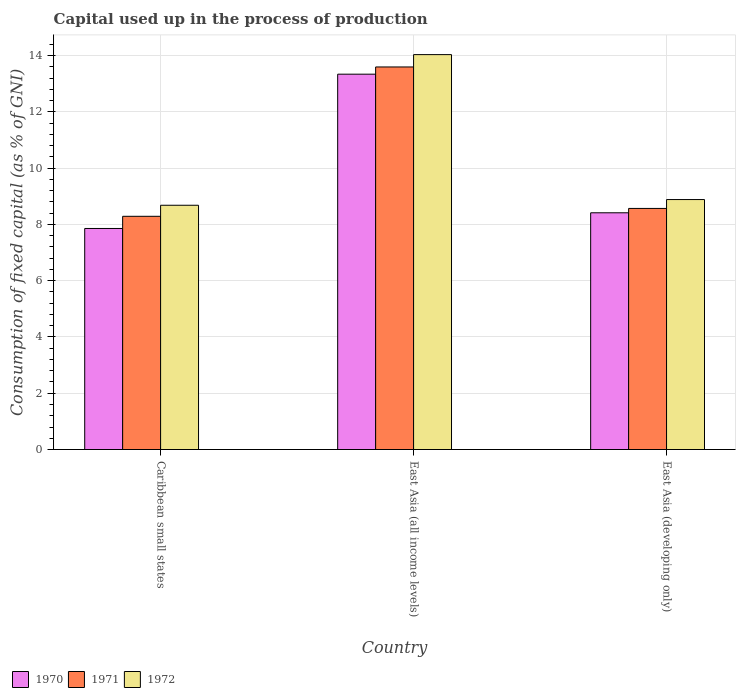How many different coloured bars are there?
Your answer should be compact. 3. How many groups of bars are there?
Offer a terse response. 3. Are the number of bars per tick equal to the number of legend labels?
Offer a very short reply. Yes. Are the number of bars on each tick of the X-axis equal?
Your response must be concise. Yes. How many bars are there on the 2nd tick from the left?
Your response must be concise. 3. What is the label of the 3rd group of bars from the left?
Your response must be concise. East Asia (developing only). In how many cases, is the number of bars for a given country not equal to the number of legend labels?
Provide a short and direct response. 0. What is the capital used up in the process of production in 1972 in East Asia (all income levels)?
Your answer should be compact. 14.03. Across all countries, what is the maximum capital used up in the process of production in 1971?
Keep it short and to the point. 13.59. Across all countries, what is the minimum capital used up in the process of production in 1971?
Give a very brief answer. 8.29. In which country was the capital used up in the process of production in 1972 maximum?
Keep it short and to the point. East Asia (all income levels). In which country was the capital used up in the process of production in 1970 minimum?
Offer a terse response. Caribbean small states. What is the total capital used up in the process of production in 1970 in the graph?
Provide a short and direct response. 29.6. What is the difference between the capital used up in the process of production in 1970 in Caribbean small states and that in East Asia (all income levels)?
Provide a short and direct response. -5.48. What is the difference between the capital used up in the process of production in 1972 in East Asia (all income levels) and the capital used up in the process of production in 1970 in East Asia (developing only)?
Give a very brief answer. 5.62. What is the average capital used up in the process of production in 1972 per country?
Provide a short and direct response. 10.53. What is the difference between the capital used up in the process of production of/in 1970 and capital used up in the process of production of/in 1971 in East Asia (developing only)?
Offer a very short reply. -0.16. In how many countries, is the capital used up in the process of production in 1971 greater than 12.8 %?
Your answer should be compact. 1. What is the ratio of the capital used up in the process of production in 1972 in Caribbean small states to that in East Asia (all income levels)?
Ensure brevity in your answer.  0.62. What is the difference between the highest and the second highest capital used up in the process of production in 1972?
Offer a very short reply. 0.2. What is the difference between the highest and the lowest capital used up in the process of production in 1972?
Ensure brevity in your answer.  5.35. Is the sum of the capital used up in the process of production in 1970 in East Asia (all income levels) and East Asia (developing only) greater than the maximum capital used up in the process of production in 1971 across all countries?
Offer a very short reply. Yes. What does the 2nd bar from the left in Caribbean small states represents?
Your response must be concise. 1971. What does the 3rd bar from the right in Caribbean small states represents?
Offer a very short reply. 1970. Is it the case that in every country, the sum of the capital used up in the process of production in 1972 and capital used up in the process of production in 1970 is greater than the capital used up in the process of production in 1971?
Offer a very short reply. Yes. How many bars are there?
Provide a short and direct response. 9. What is the difference between two consecutive major ticks on the Y-axis?
Offer a terse response. 2. Are the values on the major ticks of Y-axis written in scientific E-notation?
Provide a short and direct response. No. Does the graph contain any zero values?
Provide a succinct answer. No. Where does the legend appear in the graph?
Provide a succinct answer. Bottom left. What is the title of the graph?
Give a very brief answer. Capital used up in the process of production. What is the label or title of the Y-axis?
Offer a terse response. Consumption of fixed capital (as % of GNI). What is the Consumption of fixed capital (as % of GNI) in 1970 in Caribbean small states?
Your answer should be very brief. 7.85. What is the Consumption of fixed capital (as % of GNI) in 1971 in Caribbean small states?
Provide a succinct answer. 8.29. What is the Consumption of fixed capital (as % of GNI) of 1972 in Caribbean small states?
Your response must be concise. 8.68. What is the Consumption of fixed capital (as % of GNI) in 1970 in East Asia (all income levels)?
Provide a succinct answer. 13.34. What is the Consumption of fixed capital (as % of GNI) in 1971 in East Asia (all income levels)?
Provide a short and direct response. 13.59. What is the Consumption of fixed capital (as % of GNI) of 1972 in East Asia (all income levels)?
Offer a very short reply. 14.03. What is the Consumption of fixed capital (as % of GNI) in 1970 in East Asia (developing only)?
Your response must be concise. 8.41. What is the Consumption of fixed capital (as % of GNI) in 1971 in East Asia (developing only)?
Keep it short and to the point. 8.57. What is the Consumption of fixed capital (as % of GNI) of 1972 in East Asia (developing only)?
Your answer should be compact. 8.88. Across all countries, what is the maximum Consumption of fixed capital (as % of GNI) in 1970?
Give a very brief answer. 13.34. Across all countries, what is the maximum Consumption of fixed capital (as % of GNI) in 1971?
Offer a very short reply. 13.59. Across all countries, what is the maximum Consumption of fixed capital (as % of GNI) in 1972?
Provide a short and direct response. 14.03. Across all countries, what is the minimum Consumption of fixed capital (as % of GNI) in 1970?
Offer a terse response. 7.85. Across all countries, what is the minimum Consumption of fixed capital (as % of GNI) in 1971?
Provide a short and direct response. 8.29. Across all countries, what is the minimum Consumption of fixed capital (as % of GNI) of 1972?
Give a very brief answer. 8.68. What is the total Consumption of fixed capital (as % of GNI) in 1970 in the graph?
Keep it short and to the point. 29.6. What is the total Consumption of fixed capital (as % of GNI) in 1971 in the graph?
Ensure brevity in your answer.  30.45. What is the total Consumption of fixed capital (as % of GNI) in 1972 in the graph?
Offer a terse response. 31.59. What is the difference between the Consumption of fixed capital (as % of GNI) of 1970 in Caribbean small states and that in East Asia (all income levels)?
Keep it short and to the point. -5.48. What is the difference between the Consumption of fixed capital (as % of GNI) of 1971 in Caribbean small states and that in East Asia (all income levels)?
Give a very brief answer. -5.31. What is the difference between the Consumption of fixed capital (as % of GNI) of 1972 in Caribbean small states and that in East Asia (all income levels)?
Offer a very short reply. -5.35. What is the difference between the Consumption of fixed capital (as % of GNI) in 1970 in Caribbean small states and that in East Asia (developing only)?
Keep it short and to the point. -0.56. What is the difference between the Consumption of fixed capital (as % of GNI) of 1971 in Caribbean small states and that in East Asia (developing only)?
Your response must be concise. -0.28. What is the difference between the Consumption of fixed capital (as % of GNI) of 1972 in Caribbean small states and that in East Asia (developing only)?
Provide a succinct answer. -0.2. What is the difference between the Consumption of fixed capital (as % of GNI) of 1970 in East Asia (all income levels) and that in East Asia (developing only)?
Make the answer very short. 4.93. What is the difference between the Consumption of fixed capital (as % of GNI) of 1971 in East Asia (all income levels) and that in East Asia (developing only)?
Make the answer very short. 5.03. What is the difference between the Consumption of fixed capital (as % of GNI) of 1972 in East Asia (all income levels) and that in East Asia (developing only)?
Provide a succinct answer. 5.15. What is the difference between the Consumption of fixed capital (as % of GNI) of 1970 in Caribbean small states and the Consumption of fixed capital (as % of GNI) of 1971 in East Asia (all income levels)?
Your answer should be compact. -5.74. What is the difference between the Consumption of fixed capital (as % of GNI) of 1970 in Caribbean small states and the Consumption of fixed capital (as % of GNI) of 1972 in East Asia (all income levels)?
Keep it short and to the point. -6.18. What is the difference between the Consumption of fixed capital (as % of GNI) in 1971 in Caribbean small states and the Consumption of fixed capital (as % of GNI) in 1972 in East Asia (all income levels)?
Provide a short and direct response. -5.75. What is the difference between the Consumption of fixed capital (as % of GNI) in 1970 in Caribbean small states and the Consumption of fixed capital (as % of GNI) in 1971 in East Asia (developing only)?
Offer a terse response. -0.71. What is the difference between the Consumption of fixed capital (as % of GNI) in 1970 in Caribbean small states and the Consumption of fixed capital (as % of GNI) in 1972 in East Asia (developing only)?
Offer a very short reply. -1.03. What is the difference between the Consumption of fixed capital (as % of GNI) of 1971 in Caribbean small states and the Consumption of fixed capital (as % of GNI) of 1972 in East Asia (developing only)?
Your answer should be compact. -0.6. What is the difference between the Consumption of fixed capital (as % of GNI) in 1970 in East Asia (all income levels) and the Consumption of fixed capital (as % of GNI) in 1971 in East Asia (developing only)?
Keep it short and to the point. 4.77. What is the difference between the Consumption of fixed capital (as % of GNI) of 1970 in East Asia (all income levels) and the Consumption of fixed capital (as % of GNI) of 1972 in East Asia (developing only)?
Your response must be concise. 4.45. What is the difference between the Consumption of fixed capital (as % of GNI) of 1971 in East Asia (all income levels) and the Consumption of fixed capital (as % of GNI) of 1972 in East Asia (developing only)?
Give a very brief answer. 4.71. What is the average Consumption of fixed capital (as % of GNI) in 1970 per country?
Ensure brevity in your answer.  9.87. What is the average Consumption of fixed capital (as % of GNI) in 1971 per country?
Your response must be concise. 10.15. What is the average Consumption of fixed capital (as % of GNI) of 1972 per country?
Provide a succinct answer. 10.53. What is the difference between the Consumption of fixed capital (as % of GNI) of 1970 and Consumption of fixed capital (as % of GNI) of 1971 in Caribbean small states?
Offer a very short reply. -0.43. What is the difference between the Consumption of fixed capital (as % of GNI) of 1970 and Consumption of fixed capital (as % of GNI) of 1972 in Caribbean small states?
Your response must be concise. -0.83. What is the difference between the Consumption of fixed capital (as % of GNI) in 1971 and Consumption of fixed capital (as % of GNI) in 1972 in Caribbean small states?
Offer a very short reply. -0.39. What is the difference between the Consumption of fixed capital (as % of GNI) of 1970 and Consumption of fixed capital (as % of GNI) of 1971 in East Asia (all income levels)?
Ensure brevity in your answer.  -0.26. What is the difference between the Consumption of fixed capital (as % of GNI) of 1970 and Consumption of fixed capital (as % of GNI) of 1972 in East Asia (all income levels)?
Keep it short and to the point. -0.7. What is the difference between the Consumption of fixed capital (as % of GNI) of 1971 and Consumption of fixed capital (as % of GNI) of 1972 in East Asia (all income levels)?
Provide a short and direct response. -0.44. What is the difference between the Consumption of fixed capital (as % of GNI) of 1970 and Consumption of fixed capital (as % of GNI) of 1971 in East Asia (developing only)?
Offer a very short reply. -0.16. What is the difference between the Consumption of fixed capital (as % of GNI) of 1970 and Consumption of fixed capital (as % of GNI) of 1972 in East Asia (developing only)?
Your answer should be very brief. -0.47. What is the difference between the Consumption of fixed capital (as % of GNI) of 1971 and Consumption of fixed capital (as % of GNI) of 1972 in East Asia (developing only)?
Provide a succinct answer. -0.32. What is the ratio of the Consumption of fixed capital (as % of GNI) in 1970 in Caribbean small states to that in East Asia (all income levels)?
Offer a terse response. 0.59. What is the ratio of the Consumption of fixed capital (as % of GNI) of 1971 in Caribbean small states to that in East Asia (all income levels)?
Your answer should be very brief. 0.61. What is the ratio of the Consumption of fixed capital (as % of GNI) in 1972 in Caribbean small states to that in East Asia (all income levels)?
Provide a succinct answer. 0.62. What is the ratio of the Consumption of fixed capital (as % of GNI) in 1970 in Caribbean small states to that in East Asia (developing only)?
Offer a terse response. 0.93. What is the ratio of the Consumption of fixed capital (as % of GNI) of 1971 in Caribbean small states to that in East Asia (developing only)?
Provide a short and direct response. 0.97. What is the ratio of the Consumption of fixed capital (as % of GNI) in 1972 in Caribbean small states to that in East Asia (developing only)?
Ensure brevity in your answer.  0.98. What is the ratio of the Consumption of fixed capital (as % of GNI) of 1970 in East Asia (all income levels) to that in East Asia (developing only)?
Offer a terse response. 1.59. What is the ratio of the Consumption of fixed capital (as % of GNI) in 1971 in East Asia (all income levels) to that in East Asia (developing only)?
Give a very brief answer. 1.59. What is the ratio of the Consumption of fixed capital (as % of GNI) in 1972 in East Asia (all income levels) to that in East Asia (developing only)?
Give a very brief answer. 1.58. What is the difference between the highest and the second highest Consumption of fixed capital (as % of GNI) in 1970?
Make the answer very short. 4.93. What is the difference between the highest and the second highest Consumption of fixed capital (as % of GNI) of 1971?
Offer a terse response. 5.03. What is the difference between the highest and the second highest Consumption of fixed capital (as % of GNI) of 1972?
Provide a succinct answer. 5.15. What is the difference between the highest and the lowest Consumption of fixed capital (as % of GNI) in 1970?
Your answer should be compact. 5.48. What is the difference between the highest and the lowest Consumption of fixed capital (as % of GNI) in 1971?
Make the answer very short. 5.31. What is the difference between the highest and the lowest Consumption of fixed capital (as % of GNI) in 1972?
Ensure brevity in your answer.  5.35. 